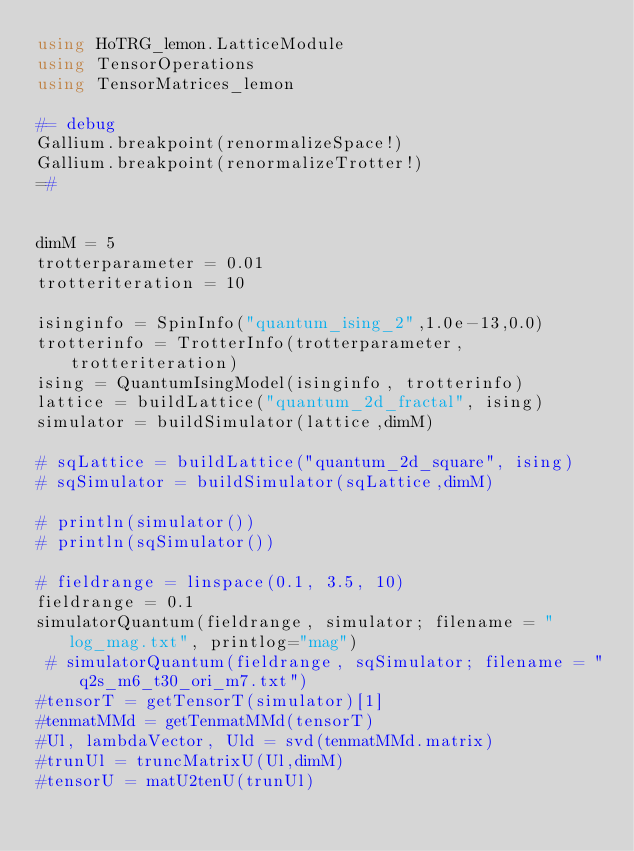Convert code to text. <code><loc_0><loc_0><loc_500><loc_500><_Julia_>using HoTRG_lemon.LatticeModule
using TensorOperations
using TensorMatrices_lemon

#= debug
Gallium.breakpoint(renormalizeSpace!)
Gallium.breakpoint(renormalizeTrotter!)
=# 


dimM = 5
trotterparameter = 0.01
trotteriteration = 10

isinginfo = SpinInfo("quantum_ising_2",1.0e-13,0.0)
trotterinfo = TrotterInfo(trotterparameter, trotteriteration)
ising = QuantumIsingModel(isinginfo, trotterinfo)
lattice = buildLattice("quantum_2d_fractal", ising)
simulator = buildSimulator(lattice,dimM)

# sqLattice = buildLattice("quantum_2d_square", ising)
# sqSimulator = buildSimulator(sqLattice,dimM)

# println(simulator())
# println(sqSimulator())

# fieldrange = linspace(0.1, 3.5, 10)
fieldrange = 0.1
simulatorQuantum(fieldrange, simulator; filename = "log_mag.txt", printlog="mag")
 # simulatorQuantum(fieldrange, sqSimulator; filename = "q2s_m6_t30_ori_m7.txt")
#tensorT = getTensorT(simulator)[1]
#tenmatMMd = getTenmatMMd(tensorT)
#Ul, lambdaVector, Uld = svd(tenmatMMd.matrix)
#trunUl = truncMatrixU(Ul,dimM)
#tensorU = matU2tenU(trunUl)
</code> 